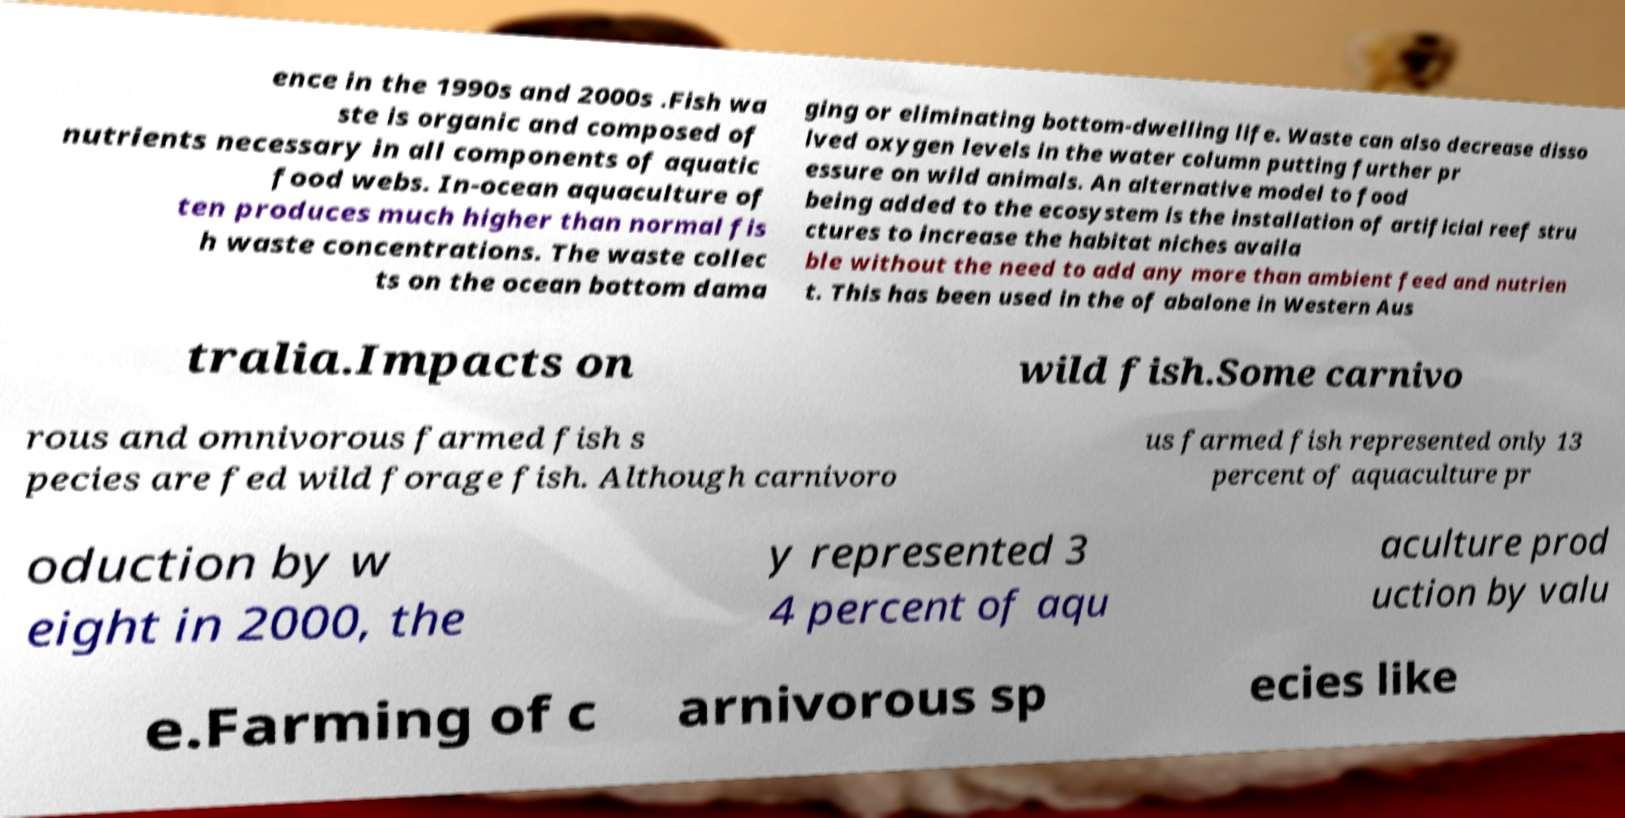Can you read and provide the text displayed in the image?This photo seems to have some interesting text. Can you extract and type it out for me? ence in the 1990s and 2000s .Fish wa ste is organic and composed of nutrients necessary in all components of aquatic food webs. In-ocean aquaculture of ten produces much higher than normal fis h waste concentrations. The waste collec ts on the ocean bottom dama ging or eliminating bottom-dwelling life. Waste can also decrease disso lved oxygen levels in the water column putting further pr essure on wild animals. An alternative model to food being added to the ecosystem is the installation of artificial reef stru ctures to increase the habitat niches availa ble without the need to add any more than ambient feed and nutrien t. This has been used in the of abalone in Western Aus tralia.Impacts on wild fish.Some carnivo rous and omnivorous farmed fish s pecies are fed wild forage fish. Although carnivoro us farmed fish represented only 13 percent of aquaculture pr oduction by w eight in 2000, the y represented 3 4 percent of aqu aculture prod uction by valu e.Farming of c arnivorous sp ecies like 